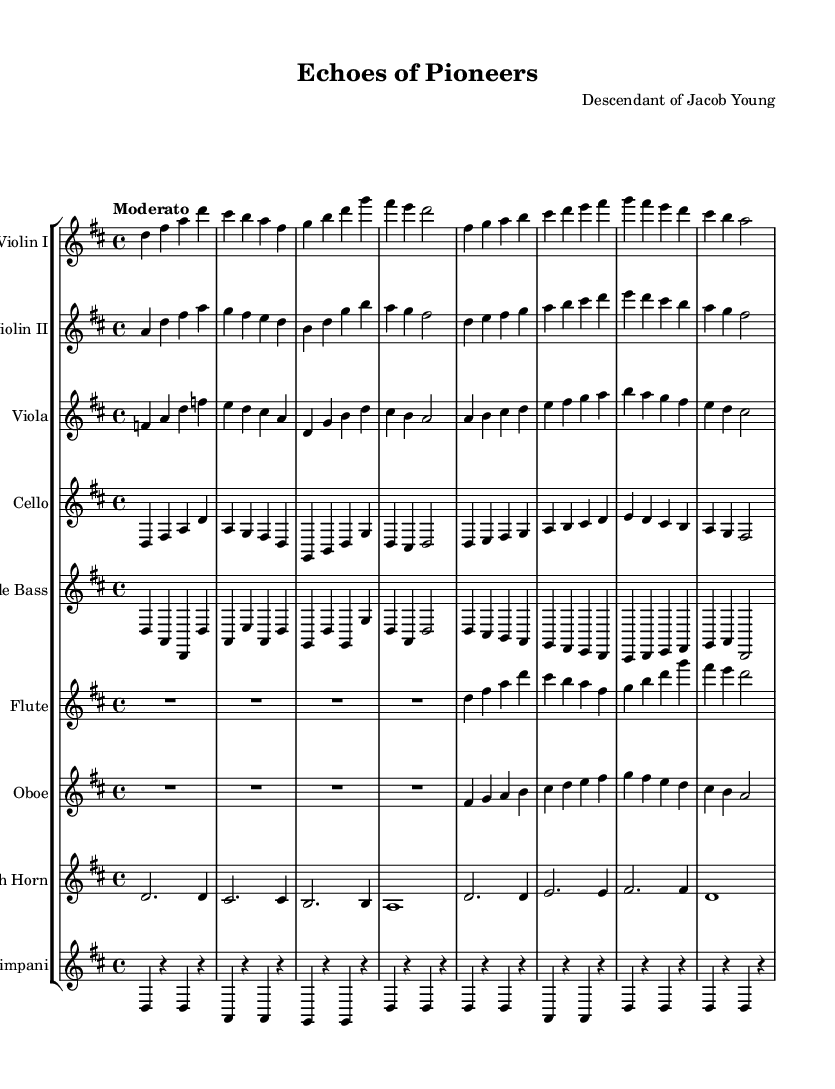What is the key signature of this music? The key signature is indicated at the beginning of the score with sharp symbols. In this case, there are two sharps, which corresponds to D major.
Answer: D major What is the time signature of this composition? The time signature appears at the beginning of the score, notated as a fraction. It shows four beats per measure, thus it is 4/4 time.
Answer: 4/4 What tempo marking is used in this piece? The tempo is specified right at the beginning of the score with the term "Moderato," which guides the speed of the performance.
Answer: Moderato How many instruments are in this orchestral composition? By counting the individual staves in the score, we see there are nine staves, each representing a different instrument.
Answer: Nine What is the main theme's title? The title is provided in the header section of the score, stating the work as "Echoes of Pioneers."
Answer: Echoes of Pioneers Which string instrument plays the highest notes? Looking at the ranges of the parts, the Violin I, marked as the highest instrument, plays at a higher pitch relative to the other string instruments.
Answer: Violin I What instrument plays a rhythmic role in this score? The Timpani, indicated within its own staff, primarily plays rhythmic patterns, providing accents and pulse to the orchestration.
Answer: Timpani 